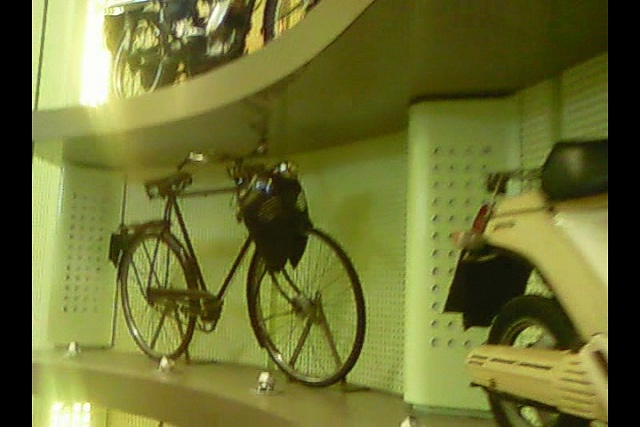Describe the objects in this image and their specific colors. I can see motorcycle in black, tan, and olive tones, bicycle in black and olive tones, and bicycle in black, olive, and khaki tones in this image. 